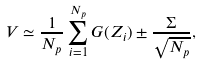Convert formula to latex. <formula><loc_0><loc_0><loc_500><loc_500>V \simeq \frac { 1 } { N _ { p } } \sum _ { i = 1 } ^ { N _ { p } } G ( Z _ { i } ) \pm \frac { \Sigma } { \sqrt { N _ { p } } } ,</formula> 